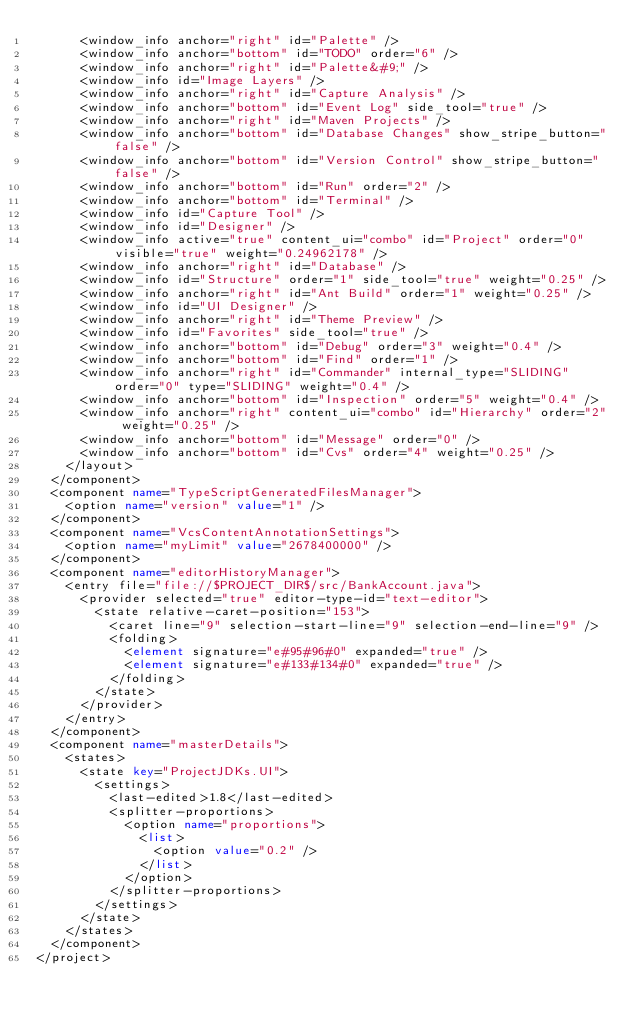<code> <loc_0><loc_0><loc_500><loc_500><_XML_>      <window_info anchor="right" id="Palette" />
      <window_info anchor="bottom" id="TODO" order="6" />
      <window_info anchor="right" id="Palette&#9;" />
      <window_info id="Image Layers" />
      <window_info anchor="right" id="Capture Analysis" />
      <window_info anchor="bottom" id="Event Log" side_tool="true" />
      <window_info anchor="right" id="Maven Projects" />
      <window_info anchor="bottom" id="Database Changes" show_stripe_button="false" />
      <window_info anchor="bottom" id="Version Control" show_stripe_button="false" />
      <window_info anchor="bottom" id="Run" order="2" />
      <window_info anchor="bottom" id="Terminal" />
      <window_info id="Capture Tool" />
      <window_info id="Designer" />
      <window_info active="true" content_ui="combo" id="Project" order="0" visible="true" weight="0.24962178" />
      <window_info anchor="right" id="Database" />
      <window_info id="Structure" order="1" side_tool="true" weight="0.25" />
      <window_info anchor="right" id="Ant Build" order="1" weight="0.25" />
      <window_info id="UI Designer" />
      <window_info anchor="right" id="Theme Preview" />
      <window_info id="Favorites" side_tool="true" />
      <window_info anchor="bottom" id="Debug" order="3" weight="0.4" />
      <window_info anchor="bottom" id="Find" order="1" />
      <window_info anchor="right" id="Commander" internal_type="SLIDING" order="0" type="SLIDING" weight="0.4" />
      <window_info anchor="bottom" id="Inspection" order="5" weight="0.4" />
      <window_info anchor="right" content_ui="combo" id="Hierarchy" order="2" weight="0.25" />
      <window_info anchor="bottom" id="Message" order="0" />
      <window_info anchor="bottom" id="Cvs" order="4" weight="0.25" />
    </layout>
  </component>
  <component name="TypeScriptGeneratedFilesManager">
    <option name="version" value="1" />
  </component>
  <component name="VcsContentAnnotationSettings">
    <option name="myLimit" value="2678400000" />
  </component>
  <component name="editorHistoryManager">
    <entry file="file://$PROJECT_DIR$/src/BankAccount.java">
      <provider selected="true" editor-type-id="text-editor">
        <state relative-caret-position="153">
          <caret line="9" selection-start-line="9" selection-end-line="9" />
          <folding>
            <element signature="e#95#96#0" expanded="true" />
            <element signature="e#133#134#0" expanded="true" />
          </folding>
        </state>
      </provider>
    </entry>
  </component>
  <component name="masterDetails">
    <states>
      <state key="ProjectJDKs.UI">
        <settings>
          <last-edited>1.8</last-edited>
          <splitter-proportions>
            <option name="proportions">
              <list>
                <option value="0.2" />
              </list>
            </option>
          </splitter-proportions>
        </settings>
      </state>
    </states>
  </component>
</project></code> 